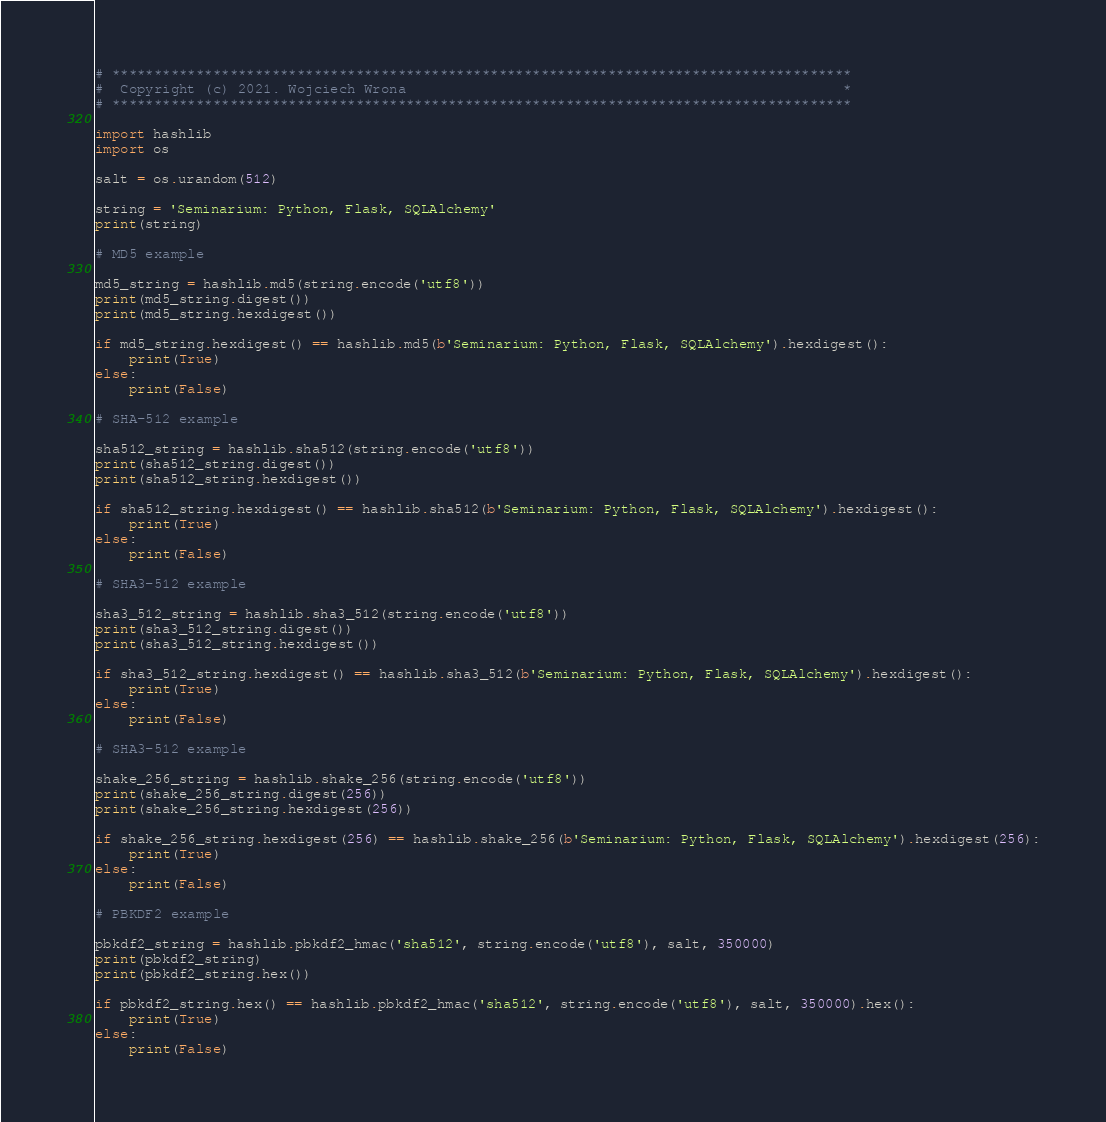<code> <loc_0><loc_0><loc_500><loc_500><_Python_># ****************************************************************************************
#  Copyright (c) 2021. Wojciech Wrona                                                    *
# ****************************************************************************************

import hashlib
import os

salt = os.urandom(512)

string = 'Seminarium: Python, Flask, SQLAlchemy'
print(string)

# MD5 example

md5_string = hashlib.md5(string.encode('utf8'))
print(md5_string.digest())
print(md5_string.hexdigest())

if md5_string.hexdigest() == hashlib.md5(b'Seminarium: Python, Flask, SQLAlchemy').hexdigest():
    print(True)
else:
    print(False)

# SHA-512 example

sha512_string = hashlib.sha512(string.encode('utf8'))
print(sha512_string.digest())
print(sha512_string.hexdigest())

if sha512_string.hexdigest() == hashlib.sha512(b'Seminarium: Python, Flask, SQLAlchemy').hexdigest():
    print(True)
else:
    print(False)

# SHA3-512 example

sha3_512_string = hashlib.sha3_512(string.encode('utf8'))
print(sha3_512_string.digest())
print(sha3_512_string.hexdigest())

if sha3_512_string.hexdigest() == hashlib.sha3_512(b'Seminarium: Python, Flask, SQLAlchemy').hexdigest():
    print(True)
else:
    print(False)

# SHA3-512 example

shake_256_string = hashlib.shake_256(string.encode('utf8'))
print(shake_256_string.digest(256))
print(shake_256_string.hexdigest(256))

if shake_256_string.hexdigest(256) == hashlib.shake_256(b'Seminarium: Python, Flask, SQLAlchemy').hexdigest(256):
    print(True)
else:
    print(False)

# PBKDF2 example

pbkdf2_string = hashlib.pbkdf2_hmac('sha512', string.encode('utf8'), salt, 350000)
print(pbkdf2_string)
print(pbkdf2_string.hex())

if pbkdf2_string.hex() == hashlib.pbkdf2_hmac('sha512', string.encode('utf8'), salt, 350000).hex():
    print(True)
else:
    print(False)

</code> 